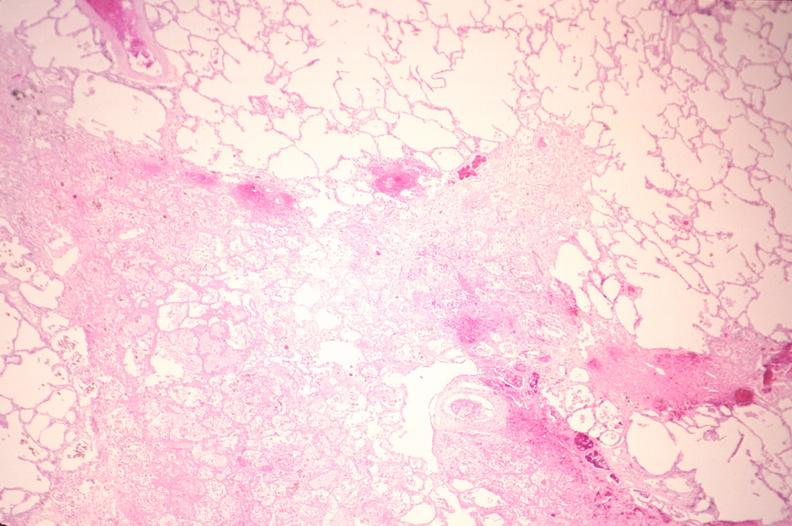where is this?
Answer the question using a single word or phrase. Lung 